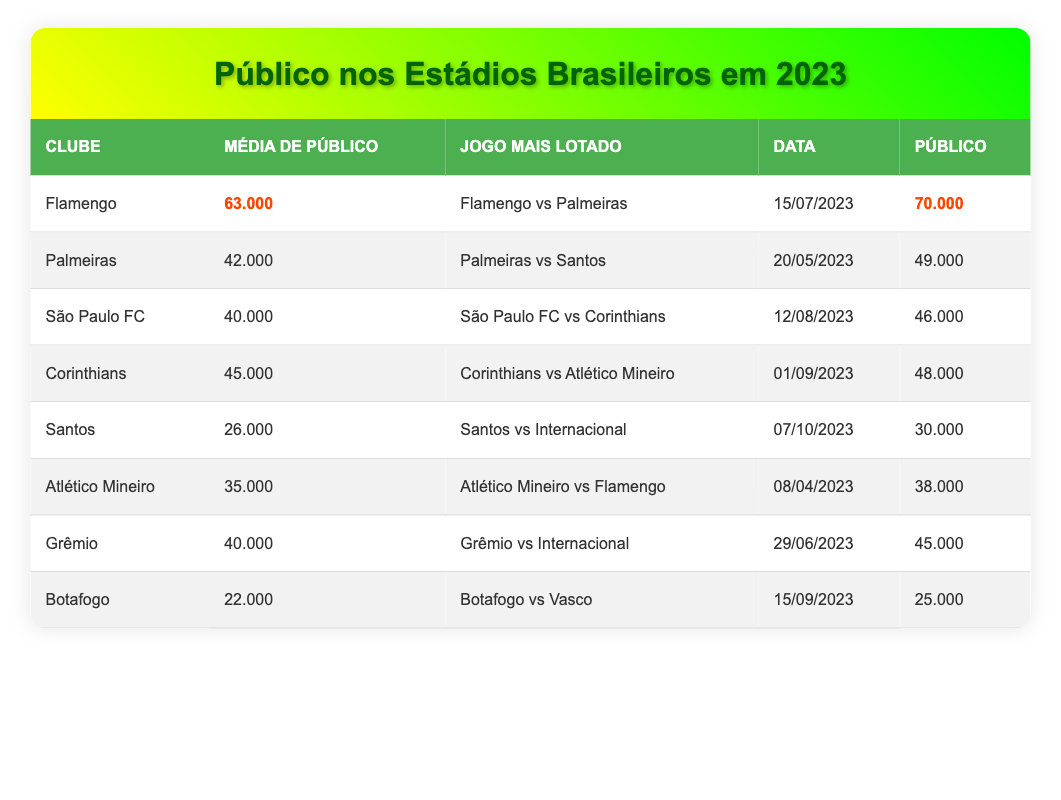What is the average attendance for Flamengo in 2023? The average attendance for Flamengo is listed in the table as 63,000.
Answer: 63000 Which match had the highest attendance in 2023? The match with the highest attendance is Flamengo vs Palmeiras with 70,000 attendees.
Answer: Flamengo vs Palmeiras How many people attended Santos' top-supported match? Santos' top-supported match against Internacional had an attendance of 30,000.
Answer: 30000 Which club has lower average attendance, Botafogo or Santos? Botafogo has an average attendance of 22,000, while Santos has 26,000. Since 22,000 is lower than 26,000, Botafogo has lower average attendance.
Answer: Botafogo What is the total attendance of the matches for Palmeiras and Corinthians? Palmeiras' attendance is 49,000 and Corinthians' attendance is 48,000. Adding these gives 49,000 + 48,000 = 97,000 total attendance.
Answer: 97000 Is the average attendance for Atlético Mineiro higher than 30,000? The average attendance for Atlético Mineiro is 35,000, which is higher than 30,000.
Answer: Yes What is the difference in average attendance between Palmeiras and Corinthians? Palmeiras has an average attendance of 42,000 and Corinthians has 45,000. The difference is 45,000 - 42,000 = 3,000.
Answer: 3000 Which club has the second-highest average attendance? Flamengo has the highest average attendance and Corinthians has the second highest with 45,000.
Answer: Corinthians If we consider the top-supported matches of Grêmio and São Paulo FC, which one had more attendees? Grêmio's match had 45,000 attendees and São Paulo FC's match had 46,000 attendees. Since 46,000 is more than 45,000, São Paulo FC's match had more attendees.
Answer: São Paulo FC's match What is the total average attendance of the three clubs with the lowest averages? The three clubs with the lowest averages are Botafogo (22,000), Santos (26,000), and Atlético Mineiro (35,000). Summing these gives 22,000 + 26,000 + 35,000 = 83,000.
Answer: 83000 